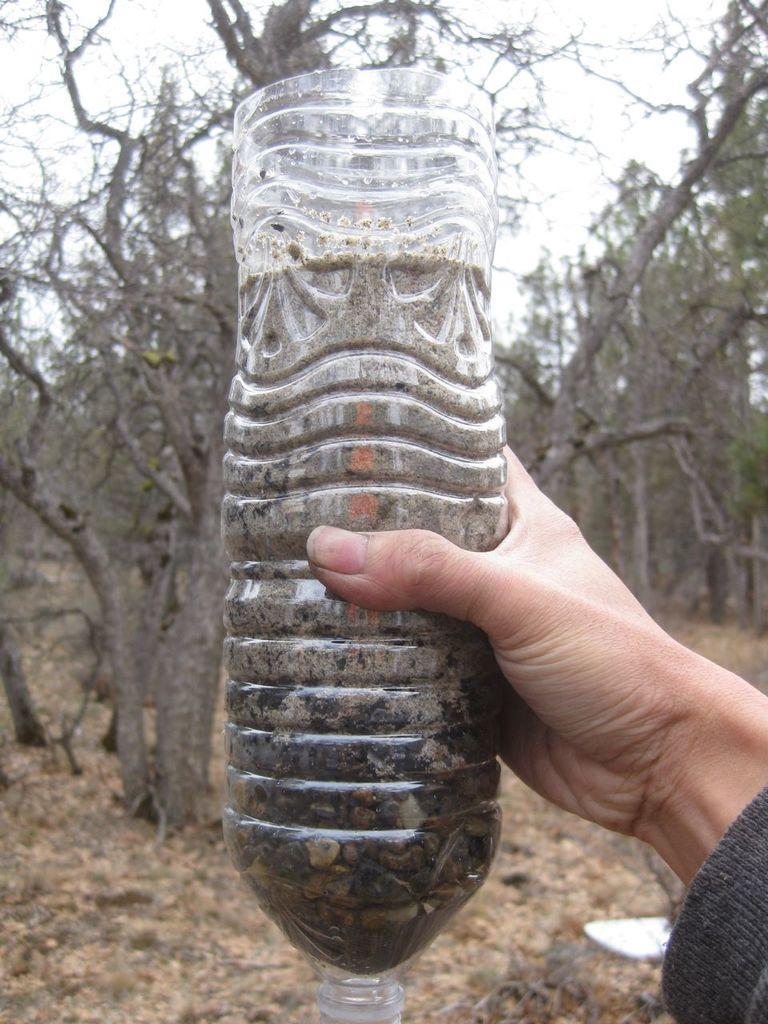How would you summarize this image in a sentence or two? In this image, we can see a bottle that is filled with a stones and some liquid. The bottle is holding by a human. We can see human hand here and some cloth here. The background we can see here few trees and sky. 